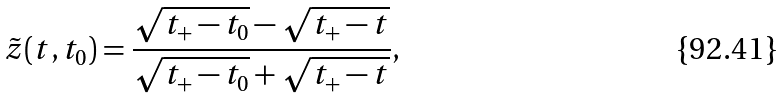Convert formula to latex. <formula><loc_0><loc_0><loc_500><loc_500>\tilde { z } ( t , t _ { 0 } ) = \frac { \sqrt { t _ { + } - t _ { 0 } } - \sqrt { t _ { + } - t } } { \sqrt { t _ { + } - t _ { 0 } } + \sqrt { t _ { + } - t } } ,</formula> 